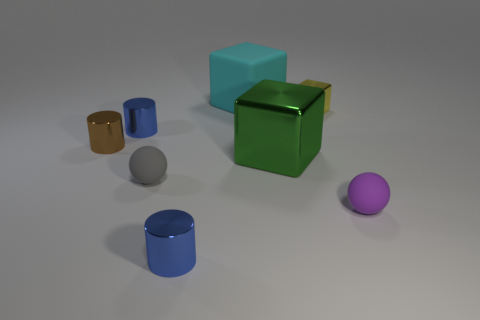Subtract all metal blocks. How many blocks are left? 1 Add 1 tiny yellow things. How many objects exist? 9 Subtract 1 purple balls. How many objects are left? 7 Subtract all cubes. How many objects are left? 5 Subtract all large shiny blocks. Subtract all small brown metallic cylinders. How many objects are left? 6 Add 1 purple rubber objects. How many purple rubber objects are left? 2 Add 6 tiny yellow objects. How many tiny yellow objects exist? 7 